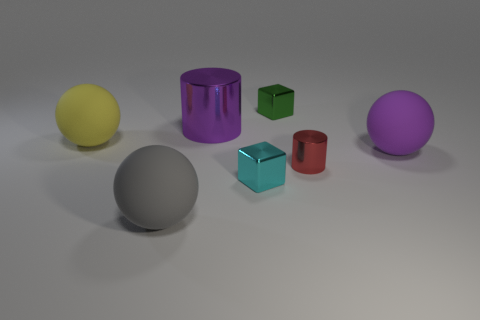There is a matte thing that is the same color as the large cylinder; what is its shape?
Your answer should be compact. Sphere. Does the rubber thing that is to the right of the green thing have the same color as the large metallic cylinder behind the cyan metallic object?
Your answer should be compact. Yes. What color is the metal cylinder that is the same size as the gray object?
Your response must be concise. Purple. Are there any big spheres that have the same color as the large cylinder?
Offer a very short reply. Yes. There is a block that is in front of the big yellow ball; is its size the same as the ball on the right side of the small red object?
Your answer should be very brief. No. There is a sphere that is both behind the cyan shiny block and to the left of the red metal cylinder; what is its material?
Ensure brevity in your answer.  Rubber. What number of other things are there of the same size as the yellow rubber thing?
Provide a succinct answer. 3. There is a tiny thing right of the green block; what is its material?
Offer a very short reply. Metal. Do the cyan shiny thing and the big purple matte thing have the same shape?
Provide a succinct answer. No. How many other objects are there of the same shape as the big purple rubber thing?
Give a very brief answer. 2. 